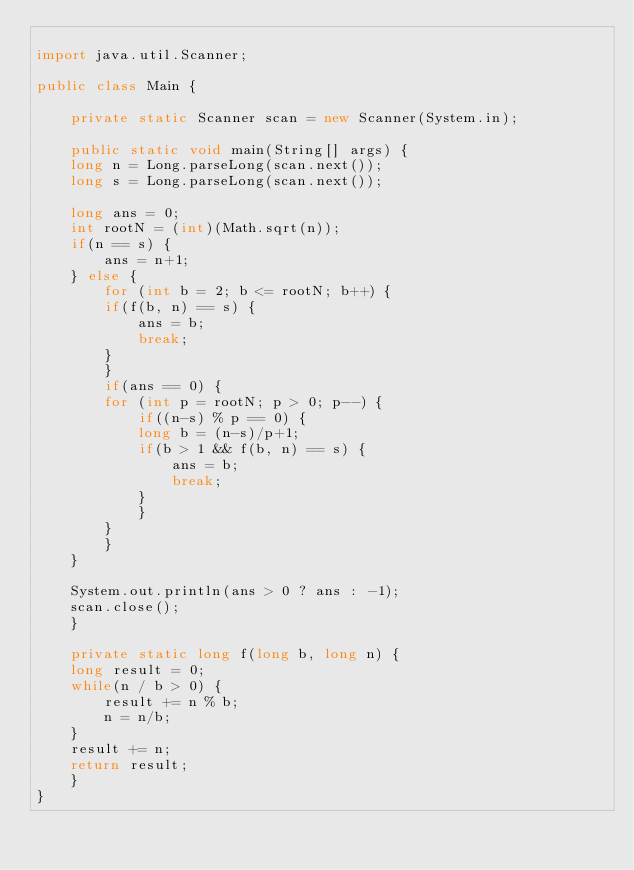Convert code to text. <code><loc_0><loc_0><loc_500><loc_500><_Java_>
import java.util.Scanner;

public class Main {

    private static Scanner scan = new Scanner(System.in);

    public static void main(String[] args) {
	long n = Long.parseLong(scan.next());
	long s = Long.parseLong(scan.next());

	long ans = 0;
	int rootN = (int)(Math.sqrt(n));
	if(n == s) {
	    ans = n+1;
	} else {
	    for (int b = 2; b <= rootN; b++) {
		if(f(b, n) == s) {
		    ans = b;
		    break;
		}
	    }
	    if(ans == 0) {
		for (int p = rootN; p > 0; p--) {
		    if((n-s) % p == 0) {
			long b = (n-s)/p+1;
			if(b > 1 && f(b, n) == s) {
			    ans = b;
			    break;
			}
		    }
		}
	    }
	}
	
	System.out.println(ans > 0 ? ans : -1);
	scan.close();
    }

    private static long f(long b, long n) {
	long result = 0;
	while(n / b > 0) {
	    result += n % b;
	    n = n/b;
	}
	result += n;
	return result;
    }
}
</code> 